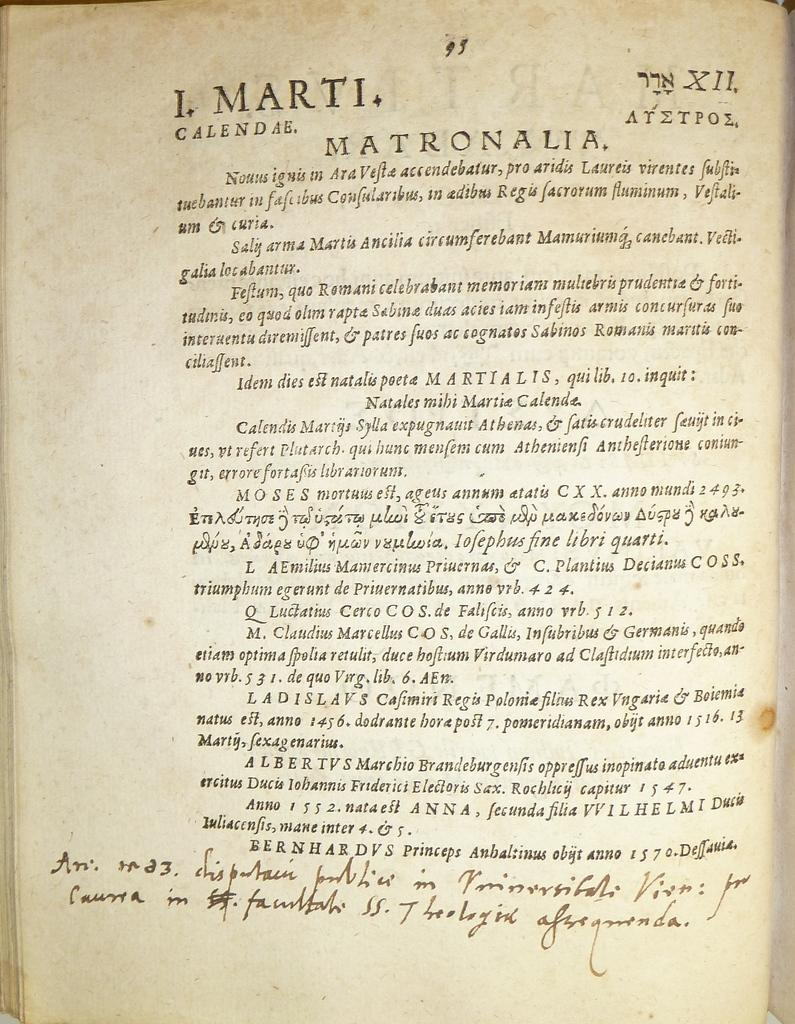<image>
Provide a brief description of the given image. A book with Hebrew writing on the top has a title Matronalia. 